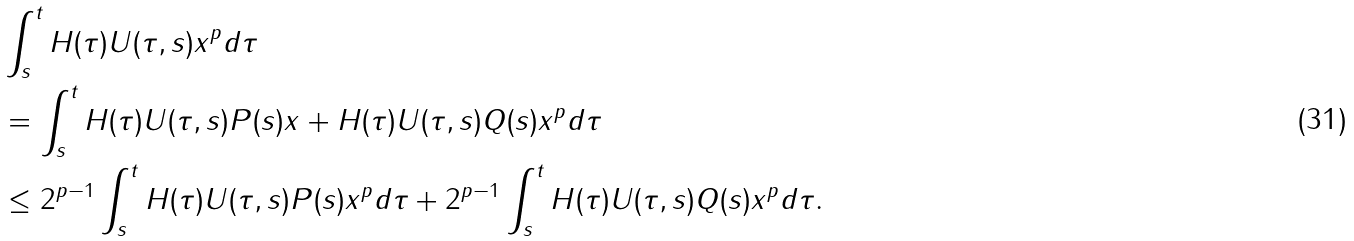Convert formula to latex. <formula><loc_0><loc_0><loc_500><loc_500>& \int _ { s } ^ { t } \| H ( \tau ) U ( \tau , s ) x \| ^ { p } d \tau \\ & = \int _ { s } ^ { t } \| H ( \tau ) U ( \tau , s ) P ( s ) x + H ( \tau ) U ( \tau , s ) Q ( s ) x \| ^ { p } d \tau \\ & \leq 2 ^ { p - 1 } \int _ { s } ^ { t } \| H ( \tau ) U ( \tau , s ) P ( s ) x \| ^ { p } d \tau + 2 ^ { p - 1 } \int _ { s } ^ { t } \| H ( \tau ) U ( \tau , s ) Q ( s ) x \| ^ { p } d \tau .</formula> 